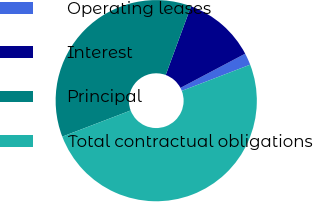<chart> <loc_0><loc_0><loc_500><loc_500><pie_chart><fcel>Operating leases<fcel>Interest<fcel>Principal<fcel>Total contractual obligations<nl><fcel>1.91%<fcel>11.64%<fcel>36.44%<fcel>50.0%<nl></chart> 